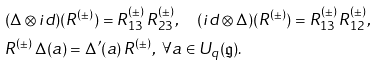Convert formula to latex. <formula><loc_0><loc_0><loc_500><loc_500>& ( \Delta \otimes i d ) ( R ^ { ( \pm ) } ) = R ^ { ( \pm ) } _ { 1 3 } \, R ^ { ( \pm ) } _ { 2 3 } , \quad ( i d \otimes \Delta ) ( R ^ { ( \pm ) } ) = R ^ { ( \pm ) } _ { 1 3 } \, R ^ { ( \pm ) } _ { 1 2 } , \\ & R ^ { ( \pm ) } \, \Delta ( a ) = \Delta ^ { \prime } ( a ) \, R ^ { ( \pm ) } , \ \forall a \in U _ { q } ( \mathfrak { g } ) .</formula> 